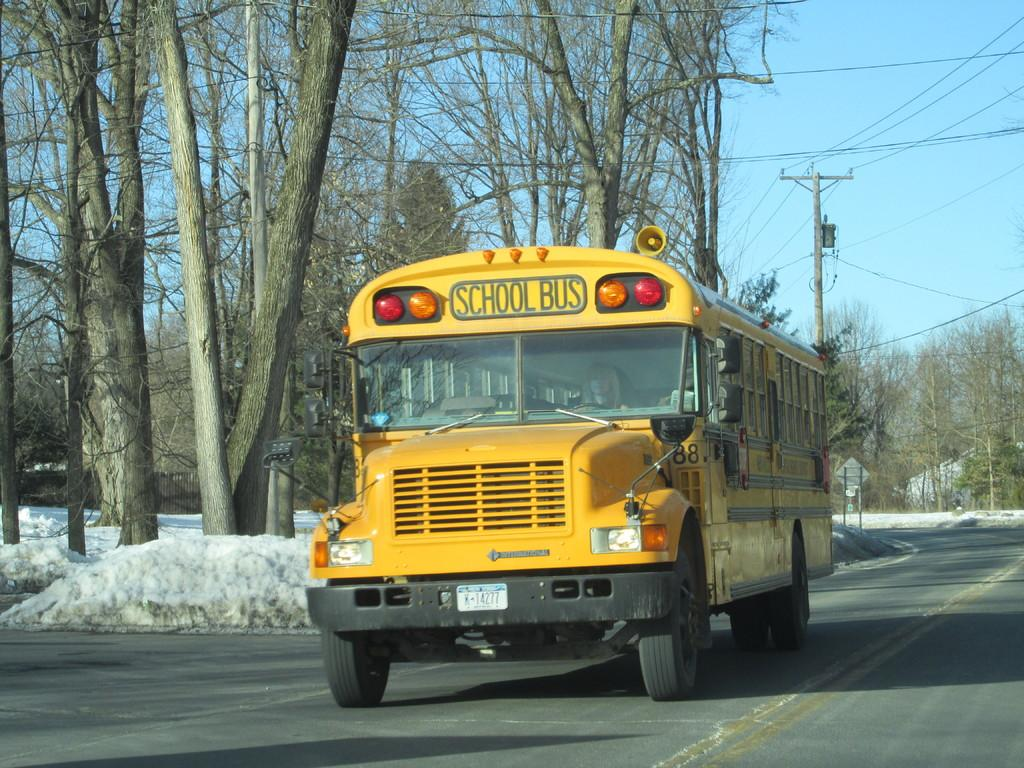<image>
Create a compact narrative representing the image presented. A yellow school bus on the road during the winter 